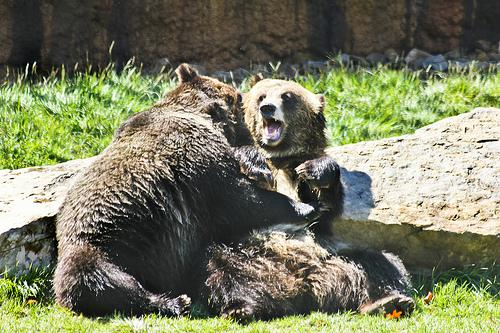Question: what type of animals are pictured?
Choices:
A. Bears.
B. Lions.
C. Wolves.
D. Tigers.
Answer with the letter. Answer: A Question: how many people are riding on elephants?
Choices:
A. 0.
B. 2.
C. 3.
D. 4.
Answer with the letter. Answer: A Question: how many elephants are pictured?
Choices:
A. 6.
B. 0.
C. 4.
D. 2.
Answer with the letter. Answer: B 